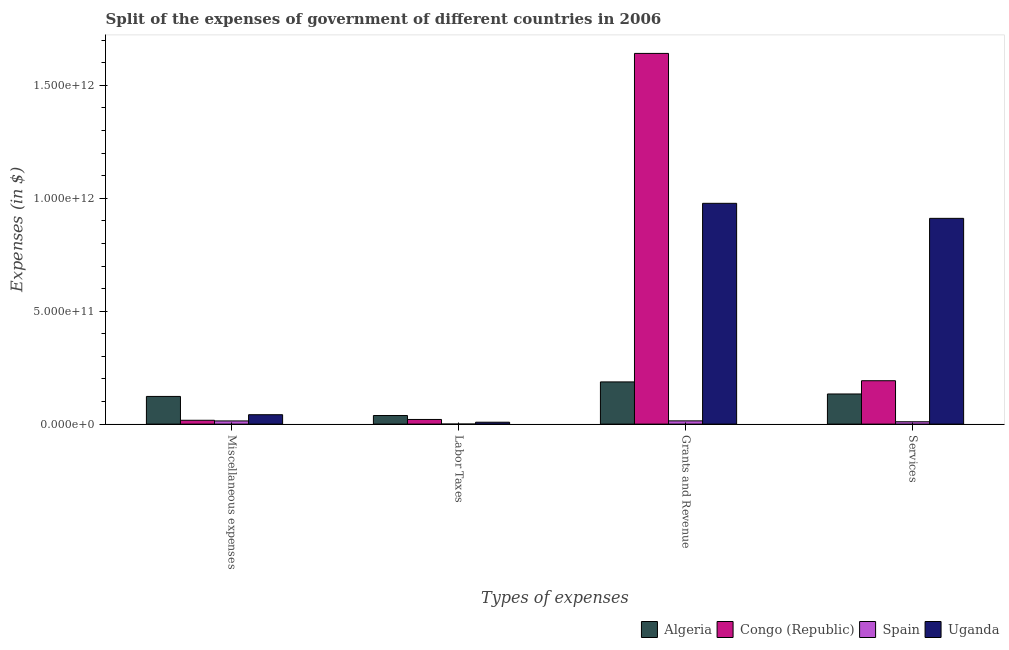How many groups of bars are there?
Keep it short and to the point. 4. Are the number of bars per tick equal to the number of legend labels?
Your answer should be very brief. Yes. Are the number of bars on each tick of the X-axis equal?
Your answer should be very brief. Yes. How many bars are there on the 4th tick from the left?
Offer a very short reply. 4. What is the label of the 3rd group of bars from the left?
Offer a very short reply. Grants and Revenue. What is the amount spent on grants and revenue in Spain?
Your response must be concise. 1.44e+1. Across all countries, what is the maximum amount spent on grants and revenue?
Offer a terse response. 1.64e+12. Across all countries, what is the minimum amount spent on services?
Ensure brevity in your answer.  1.05e+1. In which country was the amount spent on grants and revenue maximum?
Keep it short and to the point. Congo (Republic). In which country was the amount spent on miscellaneous expenses minimum?
Provide a short and direct response. Spain. What is the total amount spent on miscellaneous expenses in the graph?
Make the answer very short. 1.95e+11. What is the difference between the amount spent on labor taxes in Congo (Republic) and that in Spain?
Provide a succinct answer. 2.04e+1. What is the difference between the amount spent on grants and revenue in Congo (Republic) and the amount spent on labor taxes in Algeria?
Your answer should be very brief. 1.60e+12. What is the average amount spent on services per country?
Offer a very short reply. 3.12e+11. What is the difference between the amount spent on grants and revenue and amount spent on labor taxes in Uganda?
Provide a succinct answer. 9.69e+11. In how many countries, is the amount spent on labor taxes greater than 1000000000000 $?
Ensure brevity in your answer.  0. What is the ratio of the amount spent on miscellaneous expenses in Congo (Republic) to that in Algeria?
Your answer should be compact. 0.14. Is the difference between the amount spent on services in Algeria and Spain greater than the difference between the amount spent on labor taxes in Algeria and Spain?
Your answer should be compact. Yes. What is the difference between the highest and the second highest amount spent on miscellaneous expenses?
Offer a very short reply. 8.09e+1. What is the difference between the highest and the lowest amount spent on services?
Make the answer very short. 9.01e+11. In how many countries, is the amount spent on grants and revenue greater than the average amount spent on grants and revenue taken over all countries?
Provide a succinct answer. 2. Is it the case that in every country, the sum of the amount spent on miscellaneous expenses and amount spent on grants and revenue is greater than the sum of amount spent on services and amount spent on labor taxes?
Your answer should be compact. No. What does the 1st bar from the left in Services represents?
Your response must be concise. Algeria. What does the 1st bar from the right in Miscellaneous expenses represents?
Your response must be concise. Uganda. How many bars are there?
Provide a short and direct response. 16. Are all the bars in the graph horizontal?
Provide a succinct answer. No. What is the difference between two consecutive major ticks on the Y-axis?
Offer a terse response. 5.00e+11. Are the values on the major ticks of Y-axis written in scientific E-notation?
Offer a terse response. Yes. Where does the legend appear in the graph?
Make the answer very short. Bottom right. How are the legend labels stacked?
Your response must be concise. Horizontal. What is the title of the graph?
Make the answer very short. Split of the expenses of government of different countries in 2006. Does "Ukraine" appear as one of the legend labels in the graph?
Your response must be concise. No. What is the label or title of the X-axis?
Your answer should be compact. Types of expenses. What is the label or title of the Y-axis?
Provide a short and direct response. Expenses (in $). What is the Expenses (in $) of Algeria in Miscellaneous expenses?
Your answer should be very brief. 1.23e+11. What is the Expenses (in $) of Congo (Republic) in Miscellaneous expenses?
Provide a short and direct response. 1.70e+1. What is the Expenses (in $) in Spain in Miscellaneous expenses?
Keep it short and to the point. 1.41e+1. What is the Expenses (in $) of Uganda in Miscellaneous expenses?
Your response must be concise. 4.16e+1. What is the Expenses (in $) in Algeria in Labor Taxes?
Offer a very short reply. 3.81e+1. What is the Expenses (in $) in Congo (Republic) in Labor Taxes?
Keep it short and to the point. 2.06e+1. What is the Expenses (in $) in Spain in Labor Taxes?
Give a very brief answer. 1.53e+08. What is the Expenses (in $) of Uganda in Labor Taxes?
Offer a very short reply. 8.41e+09. What is the Expenses (in $) in Algeria in Grants and Revenue?
Offer a terse response. 1.87e+11. What is the Expenses (in $) of Congo (Republic) in Grants and Revenue?
Provide a short and direct response. 1.64e+12. What is the Expenses (in $) of Spain in Grants and Revenue?
Keep it short and to the point. 1.44e+1. What is the Expenses (in $) of Uganda in Grants and Revenue?
Offer a terse response. 9.78e+11. What is the Expenses (in $) in Algeria in Services?
Keep it short and to the point. 1.33e+11. What is the Expenses (in $) in Congo (Republic) in Services?
Provide a short and direct response. 1.92e+11. What is the Expenses (in $) in Spain in Services?
Keep it short and to the point. 1.05e+1. What is the Expenses (in $) of Uganda in Services?
Provide a short and direct response. 9.11e+11. Across all Types of expenses, what is the maximum Expenses (in $) of Algeria?
Keep it short and to the point. 1.87e+11. Across all Types of expenses, what is the maximum Expenses (in $) in Congo (Republic)?
Offer a terse response. 1.64e+12. Across all Types of expenses, what is the maximum Expenses (in $) of Spain?
Offer a very short reply. 1.44e+1. Across all Types of expenses, what is the maximum Expenses (in $) in Uganda?
Your answer should be compact. 9.78e+11. Across all Types of expenses, what is the minimum Expenses (in $) of Algeria?
Your answer should be compact. 3.81e+1. Across all Types of expenses, what is the minimum Expenses (in $) in Congo (Republic)?
Offer a terse response. 1.70e+1. Across all Types of expenses, what is the minimum Expenses (in $) of Spain?
Your response must be concise. 1.53e+08. Across all Types of expenses, what is the minimum Expenses (in $) of Uganda?
Your response must be concise. 8.41e+09. What is the total Expenses (in $) in Algeria in the graph?
Keep it short and to the point. 4.81e+11. What is the total Expenses (in $) in Congo (Republic) in the graph?
Your response must be concise. 1.87e+12. What is the total Expenses (in $) in Spain in the graph?
Provide a succinct answer. 3.91e+1. What is the total Expenses (in $) in Uganda in the graph?
Your answer should be compact. 1.94e+12. What is the difference between the Expenses (in $) in Algeria in Miscellaneous expenses and that in Labor Taxes?
Your response must be concise. 8.45e+1. What is the difference between the Expenses (in $) of Congo (Republic) in Miscellaneous expenses and that in Labor Taxes?
Your answer should be very brief. -3.60e+09. What is the difference between the Expenses (in $) of Spain in Miscellaneous expenses and that in Labor Taxes?
Ensure brevity in your answer.  1.40e+1. What is the difference between the Expenses (in $) of Uganda in Miscellaneous expenses and that in Labor Taxes?
Keep it short and to the point. 3.32e+1. What is the difference between the Expenses (in $) in Algeria in Miscellaneous expenses and that in Grants and Revenue?
Ensure brevity in your answer.  -6.43e+1. What is the difference between the Expenses (in $) in Congo (Republic) in Miscellaneous expenses and that in Grants and Revenue?
Keep it short and to the point. -1.62e+12. What is the difference between the Expenses (in $) in Spain in Miscellaneous expenses and that in Grants and Revenue?
Offer a very short reply. -2.59e+08. What is the difference between the Expenses (in $) of Uganda in Miscellaneous expenses and that in Grants and Revenue?
Provide a short and direct response. -9.36e+11. What is the difference between the Expenses (in $) of Algeria in Miscellaneous expenses and that in Services?
Make the answer very short. -1.09e+1. What is the difference between the Expenses (in $) of Congo (Republic) in Miscellaneous expenses and that in Services?
Provide a short and direct response. -1.75e+11. What is the difference between the Expenses (in $) of Spain in Miscellaneous expenses and that in Services?
Make the answer very short. 3.65e+09. What is the difference between the Expenses (in $) of Uganda in Miscellaneous expenses and that in Services?
Provide a short and direct response. -8.69e+11. What is the difference between the Expenses (in $) in Algeria in Labor Taxes and that in Grants and Revenue?
Your answer should be very brief. -1.49e+11. What is the difference between the Expenses (in $) of Congo (Republic) in Labor Taxes and that in Grants and Revenue?
Keep it short and to the point. -1.62e+12. What is the difference between the Expenses (in $) of Spain in Labor Taxes and that in Grants and Revenue?
Give a very brief answer. -1.42e+1. What is the difference between the Expenses (in $) of Uganda in Labor Taxes and that in Grants and Revenue?
Your answer should be very brief. -9.69e+11. What is the difference between the Expenses (in $) in Algeria in Labor Taxes and that in Services?
Give a very brief answer. -9.54e+1. What is the difference between the Expenses (in $) of Congo (Republic) in Labor Taxes and that in Services?
Offer a terse response. -1.72e+11. What is the difference between the Expenses (in $) of Spain in Labor Taxes and that in Services?
Give a very brief answer. -1.03e+1. What is the difference between the Expenses (in $) in Uganda in Labor Taxes and that in Services?
Offer a very short reply. -9.03e+11. What is the difference between the Expenses (in $) of Algeria in Grants and Revenue and that in Services?
Offer a terse response. 5.34e+1. What is the difference between the Expenses (in $) in Congo (Republic) in Grants and Revenue and that in Services?
Ensure brevity in your answer.  1.45e+12. What is the difference between the Expenses (in $) in Spain in Grants and Revenue and that in Services?
Your answer should be compact. 3.91e+09. What is the difference between the Expenses (in $) in Uganda in Grants and Revenue and that in Services?
Ensure brevity in your answer.  6.65e+1. What is the difference between the Expenses (in $) of Algeria in Miscellaneous expenses and the Expenses (in $) of Congo (Republic) in Labor Taxes?
Your answer should be very brief. 1.02e+11. What is the difference between the Expenses (in $) in Algeria in Miscellaneous expenses and the Expenses (in $) in Spain in Labor Taxes?
Provide a succinct answer. 1.22e+11. What is the difference between the Expenses (in $) of Algeria in Miscellaneous expenses and the Expenses (in $) of Uganda in Labor Taxes?
Keep it short and to the point. 1.14e+11. What is the difference between the Expenses (in $) of Congo (Republic) in Miscellaneous expenses and the Expenses (in $) of Spain in Labor Taxes?
Offer a very short reply. 1.68e+1. What is the difference between the Expenses (in $) in Congo (Republic) in Miscellaneous expenses and the Expenses (in $) in Uganda in Labor Taxes?
Your answer should be very brief. 8.59e+09. What is the difference between the Expenses (in $) of Spain in Miscellaneous expenses and the Expenses (in $) of Uganda in Labor Taxes?
Your answer should be compact. 5.70e+09. What is the difference between the Expenses (in $) in Algeria in Miscellaneous expenses and the Expenses (in $) in Congo (Republic) in Grants and Revenue?
Your answer should be compact. -1.52e+12. What is the difference between the Expenses (in $) of Algeria in Miscellaneous expenses and the Expenses (in $) of Spain in Grants and Revenue?
Offer a terse response. 1.08e+11. What is the difference between the Expenses (in $) of Algeria in Miscellaneous expenses and the Expenses (in $) of Uganda in Grants and Revenue?
Make the answer very short. -8.55e+11. What is the difference between the Expenses (in $) in Congo (Republic) in Miscellaneous expenses and the Expenses (in $) in Spain in Grants and Revenue?
Your response must be concise. 2.63e+09. What is the difference between the Expenses (in $) of Congo (Republic) in Miscellaneous expenses and the Expenses (in $) of Uganda in Grants and Revenue?
Provide a short and direct response. -9.61e+11. What is the difference between the Expenses (in $) in Spain in Miscellaneous expenses and the Expenses (in $) in Uganda in Grants and Revenue?
Your response must be concise. -9.63e+11. What is the difference between the Expenses (in $) in Algeria in Miscellaneous expenses and the Expenses (in $) in Congo (Republic) in Services?
Make the answer very short. -6.95e+1. What is the difference between the Expenses (in $) of Algeria in Miscellaneous expenses and the Expenses (in $) of Spain in Services?
Your response must be concise. 1.12e+11. What is the difference between the Expenses (in $) in Algeria in Miscellaneous expenses and the Expenses (in $) in Uganda in Services?
Keep it short and to the point. -7.89e+11. What is the difference between the Expenses (in $) of Congo (Republic) in Miscellaneous expenses and the Expenses (in $) of Spain in Services?
Your response must be concise. 6.54e+09. What is the difference between the Expenses (in $) in Congo (Republic) in Miscellaneous expenses and the Expenses (in $) in Uganda in Services?
Provide a succinct answer. -8.94e+11. What is the difference between the Expenses (in $) in Spain in Miscellaneous expenses and the Expenses (in $) in Uganda in Services?
Offer a very short reply. -8.97e+11. What is the difference between the Expenses (in $) in Algeria in Labor Taxes and the Expenses (in $) in Congo (Republic) in Grants and Revenue?
Provide a short and direct response. -1.60e+12. What is the difference between the Expenses (in $) of Algeria in Labor Taxes and the Expenses (in $) of Spain in Grants and Revenue?
Keep it short and to the point. 2.37e+1. What is the difference between the Expenses (in $) in Algeria in Labor Taxes and the Expenses (in $) in Uganda in Grants and Revenue?
Ensure brevity in your answer.  -9.40e+11. What is the difference between the Expenses (in $) in Congo (Republic) in Labor Taxes and the Expenses (in $) in Spain in Grants and Revenue?
Ensure brevity in your answer.  6.23e+09. What is the difference between the Expenses (in $) of Congo (Republic) in Labor Taxes and the Expenses (in $) of Uganda in Grants and Revenue?
Your response must be concise. -9.57e+11. What is the difference between the Expenses (in $) in Spain in Labor Taxes and the Expenses (in $) in Uganda in Grants and Revenue?
Keep it short and to the point. -9.77e+11. What is the difference between the Expenses (in $) in Algeria in Labor Taxes and the Expenses (in $) in Congo (Republic) in Services?
Provide a short and direct response. -1.54e+11. What is the difference between the Expenses (in $) of Algeria in Labor Taxes and the Expenses (in $) of Spain in Services?
Your response must be concise. 2.76e+1. What is the difference between the Expenses (in $) in Algeria in Labor Taxes and the Expenses (in $) in Uganda in Services?
Make the answer very short. -8.73e+11. What is the difference between the Expenses (in $) of Congo (Republic) in Labor Taxes and the Expenses (in $) of Spain in Services?
Offer a very short reply. 1.01e+1. What is the difference between the Expenses (in $) in Congo (Republic) in Labor Taxes and the Expenses (in $) in Uganda in Services?
Your answer should be compact. -8.90e+11. What is the difference between the Expenses (in $) in Spain in Labor Taxes and the Expenses (in $) in Uganda in Services?
Provide a succinct answer. -9.11e+11. What is the difference between the Expenses (in $) in Algeria in Grants and Revenue and the Expenses (in $) in Congo (Republic) in Services?
Make the answer very short. -5.22e+09. What is the difference between the Expenses (in $) in Algeria in Grants and Revenue and the Expenses (in $) in Spain in Services?
Make the answer very short. 1.76e+11. What is the difference between the Expenses (in $) in Algeria in Grants and Revenue and the Expenses (in $) in Uganda in Services?
Offer a terse response. -7.24e+11. What is the difference between the Expenses (in $) in Congo (Republic) in Grants and Revenue and the Expenses (in $) in Spain in Services?
Your response must be concise. 1.63e+12. What is the difference between the Expenses (in $) in Congo (Republic) in Grants and Revenue and the Expenses (in $) in Uganda in Services?
Offer a terse response. 7.30e+11. What is the difference between the Expenses (in $) of Spain in Grants and Revenue and the Expenses (in $) of Uganda in Services?
Provide a short and direct response. -8.97e+11. What is the average Expenses (in $) in Algeria per Types of expenses?
Ensure brevity in your answer.  1.20e+11. What is the average Expenses (in $) in Congo (Republic) per Types of expenses?
Offer a terse response. 4.68e+11. What is the average Expenses (in $) in Spain per Types of expenses?
Your answer should be very brief. 9.77e+09. What is the average Expenses (in $) in Uganda per Types of expenses?
Ensure brevity in your answer.  4.85e+11. What is the difference between the Expenses (in $) of Algeria and Expenses (in $) of Congo (Republic) in Miscellaneous expenses?
Your response must be concise. 1.06e+11. What is the difference between the Expenses (in $) of Algeria and Expenses (in $) of Spain in Miscellaneous expenses?
Make the answer very short. 1.08e+11. What is the difference between the Expenses (in $) in Algeria and Expenses (in $) in Uganda in Miscellaneous expenses?
Make the answer very short. 8.09e+1. What is the difference between the Expenses (in $) in Congo (Republic) and Expenses (in $) in Spain in Miscellaneous expenses?
Provide a short and direct response. 2.89e+09. What is the difference between the Expenses (in $) in Congo (Republic) and Expenses (in $) in Uganda in Miscellaneous expenses?
Make the answer very short. -2.46e+1. What is the difference between the Expenses (in $) of Spain and Expenses (in $) of Uganda in Miscellaneous expenses?
Your answer should be very brief. -2.75e+1. What is the difference between the Expenses (in $) in Algeria and Expenses (in $) in Congo (Republic) in Labor Taxes?
Give a very brief answer. 1.75e+1. What is the difference between the Expenses (in $) of Algeria and Expenses (in $) of Spain in Labor Taxes?
Offer a terse response. 3.79e+1. What is the difference between the Expenses (in $) of Algeria and Expenses (in $) of Uganda in Labor Taxes?
Provide a short and direct response. 2.97e+1. What is the difference between the Expenses (in $) of Congo (Republic) and Expenses (in $) of Spain in Labor Taxes?
Give a very brief answer. 2.04e+1. What is the difference between the Expenses (in $) in Congo (Republic) and Expenses (in $) in Uganda in Labor Taxes?
Offer a terse response. 1.22e+1. What is the difference between the Expenses (in $) of Spain and Expenses (in $) of Uganda in Labor Taxes?
Give a very brief answer. -8.26e+09. What is the difference between the Expenses (in $) in Algeria and Expenses (in $) in Congo (Republic) in Grants and Revenue?
Your answer should be compact. -1.45e+12. What is the difference between the Expenses (in $) in Algeria and Expenses (in $) in Spain in Grants and Revenue?
Offer a terse response. 1.73e+11. What is the difference between the Expenses (in $) of Algeria and Expenses (in $) of Uganda in Grants and Revenue?
Provide a short and direct response. -7.91e+11. What is the difference between the Expenses (in $) of Congo (Republic) and Expenses (in $) of Spain in Grants and Revenue?
Your answer should be very brief. 1.63e+12. What is the difference between the Expenses (in $) of Congo (Republic) and Expenses (in $) of Uganda in Grants and Revenue?
Give a very brief answer. 6.64e+11. What is the difference between the Expenses (in $) in Spain and Expenses (in $) in Uganda in Grants and Revenue?
Your answer should be very brief. -9.63e+11. What is the difference between the Expenses (in $) of Algeria and Expenses (in $) of Congo (Republic) in Services?
Provide a short and direct response. -5.86e+1. What is the difference between the Expenses (in $) of Algeria and Expenses (in $) of Spain in Services?
Offer a very short reply. 1.23e+11. What is the difference between the Expenses (in $) in Algeria and Expenses (in $) in Uganda in Services?
Your response must be concise. -7.78e+11. What is the difference between the Expenses (in $) of Congo (Republic) and Expenses (in $) of Spain in Services?
Your response must be concise. 1.82e+11. What is the difference between the Expenses (in $) in Congo (Republic) and Expenses (in $) in Uganda in Services?
Ensure brevity in your answer.  -7.19e+11. What is the difference between the Expenses (in $) in Spain and Expenses (in $) in Uganda in Services?
Give a very brief answer. -9.01e+11. What is the ratio of the Expenses (in $) in Algeria in Miscellaneous expenses to that in Labor Taxes?
Your answer should be compact. 3.22. What is the ratio of the Expenses (in $) in Congo (Republic) in Miscellaneous expenses to that in Labor Taxes?
Your answer should be very brief. 0.83. What is the ratio of the Expenses (in $) in Spain in Miscellaneous expenses to that in Labor Taxes?
Your answer should be compact. 92.21. What is the ratio of the Expenses (in $) in Uganda in Miscellaneous expenses to that in Labor Taxes?
Offer a very short reply. 4.95. What is the ratio of the Expenses (in $) of Algeria in Miscellaneous expenses to that in Grants and Revenue?
Give a very brief answer. 0.66. What is the ratio of the Expenses (in $) of Congo (Republic) in Miscellaneous expenses to that in Grants and Revenue?
Provide a succinct answer. 0.01. What is the ratio of the Expenses (in $) of Spain in Miscellaneous expenses to that in Grants and Revenue?
Offer a very short reply. 0.98. What is the ratio of the Expenses (in $) of Uganda in Miscellaneous expenses to that in Grants and Revenue?
Offer a very short reply. 0.04. What is the ratio of the Expenses (in $) of Algeria in Miscellaneous expenses to that in Services?
Your answer should be very brief. 0.92. What is the ratio of the Expenses (in $) in Congo (Republic) in Miscellaneous expenses to that in Services?
Make the answer very short. 0.09. What is the ratio of the Expenses (in $) in Spain in Miscellaneous expenses to that in Services?
Provide a succinct answer. 1.35. What is the ratio of the Expenses (in $) of Uganda in Miscellaneous expenses to that in Services?
Your answer should be very brief. 0.05. What is the ratio of the Expenses (in $) in Algeria in Labor Taxes to that in Grants and Revenue?
Your answer should be compact. 0.2. What is the ratio of the Expenses (in $) of Congo (Republic) in Labor Taxes to that in Grants and Revenue?
Ensure brevity in your answer.  0.01. What is the ratio of the Expenses (in $) of Spain in Labor Taxes to that in Grants and Revenue?
Keep it short and to the point. 0.01. What is the ratio of the Expenses (in $) in Uganda in Labor Taxes to that in Grants and Revenue?
Offer a terse response. 0.01. What is the ratio of the Expenses (in $) in Algeria in Labor Taxes to that in Services?
Offer a very short reply. 0.29. What is the ratio of the Expenses (in $) of Congo (Republic) in Labor Taxes to that in Services?
Your answer should be compact. 0.11. What is the ratio of the Expenses (in $) of Spain in Labor Taxes to that in Services?
Provide a succinct answer. 0.01. What is the ratio of the Expenses (in $) of Uganda in Labor Taxes to that in Services?
Ensure brevity in your answer.  0.01. What is the ratio of the Expenses (in $) of Algeria in Grants and Revenue to that in Services?
Provide a succinct answer. 1.4. What is the ratio of the Expenses (in $) in Congo (Republic) in Grants and Revenue to that in Services?
Your response must be concise. 8.54. What is the ratio of the Expenses (in $) of Spain in Grants and Revenue to that in Services?
Give a very brief answer. 1.37. What is the ratio of the Expenses (in $) of Uganda in Grants and Revenue to that in Services?
Provide a succinct answer. 1.07. What is the difference between the highest and the second highest Expenses (in $) of Algeria?
Offer a terse response. 5.34e+1. What is the difference between the highest and the second highest Expenses (in $) of Congo (Republic)?
Your answer should be very brief. 1.45e+12. What is the difference between the highest and the second highest Expenses (in $) in Spain?
Your answer should be compact. 2.59e+08. What is the difference between the highest and the second highest Expenses (in $) of Uganda?
Provide a short and direct response. 6.65e+1. What is the difference between the highest and the lowest Expenses (in $) in Algeria?
Your answer should be compact. 1.49e+11. What is the difference between the highest and the lowest Expenses (in $) of Congo (Republic)?
Make the answer very short. 1.62e+12. What is the difference between the highest and the lowest Expenses (in $) of Spain?
Your answer should be very brief. 1.42e+1. What is the difference between the highest and the lowest Expenses (in $) of Uganda?
Provide a succinct answer. 9.69e+11. 